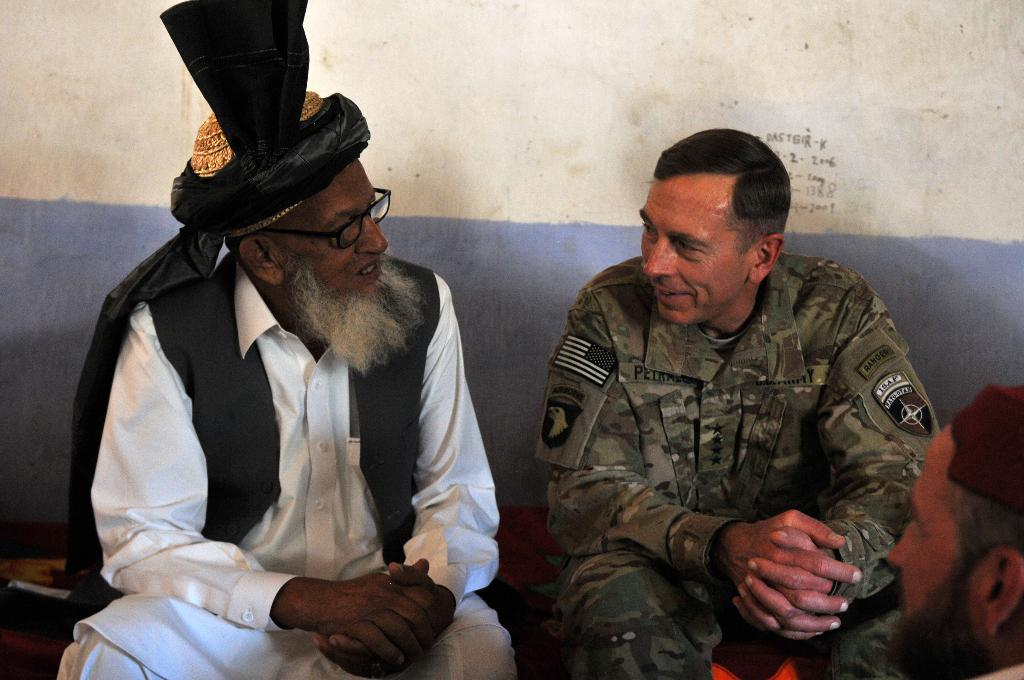How many people are present in the image? There are three people in the image. Can you describe any specific features of one of the people? One person is wearing spectacles. What can be seen in the background of the image? There is a wall in the background of the image. What type of crate is visible in the image? There is no crate present in the image. Can you describe the view from the window in the image? There is no window visible in the image, so it is not possible to describe the view. 